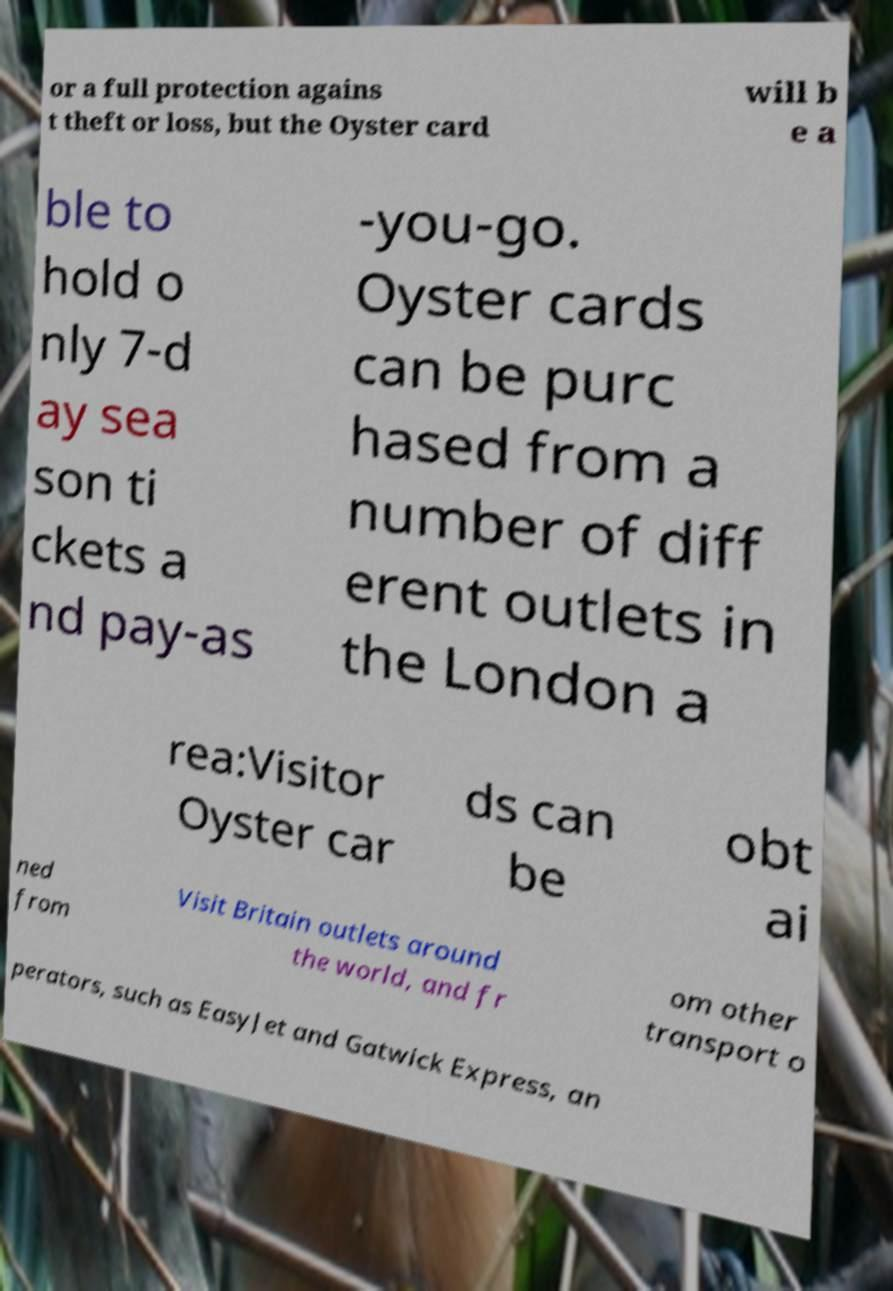Could you assist in decoding the text presented in this image and type it out clearly? or a full protection agains t theft or loss, but the Oyster card will b e a ble to hold o nly 7-d ay sea son ti ckets a nd pay-as -you-go. Oyster cards can be purc hased from a number of diff erent outlets in the London a rea:Visitor Oyster car ds can be obt ai ned from Visit Britain outlets around the world, and fr om other transport o perators, such as EasyJet and Gatwick Express, an 